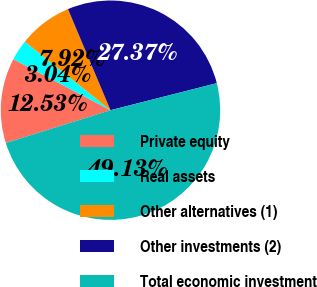Convert chart to OTSL. <chart><loc_0><loc_0><loc_500><loc_500><pie_chart><fcel>Private equity<fcel>Real assets<fcel>Other alternatives (1)<fcel>Other investments (2)<fcel>Total economic investment<nl><fcel>12.53%<fcel>3.04%<fcel>7.92%<fcel>27.37%<fcel>49.13%<nl></chart> 